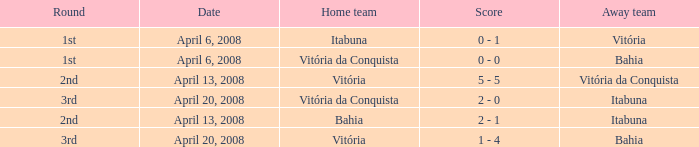What is the name of the home team with a round of 2nd and Vitória da Conquista as the way team? Vitória. 